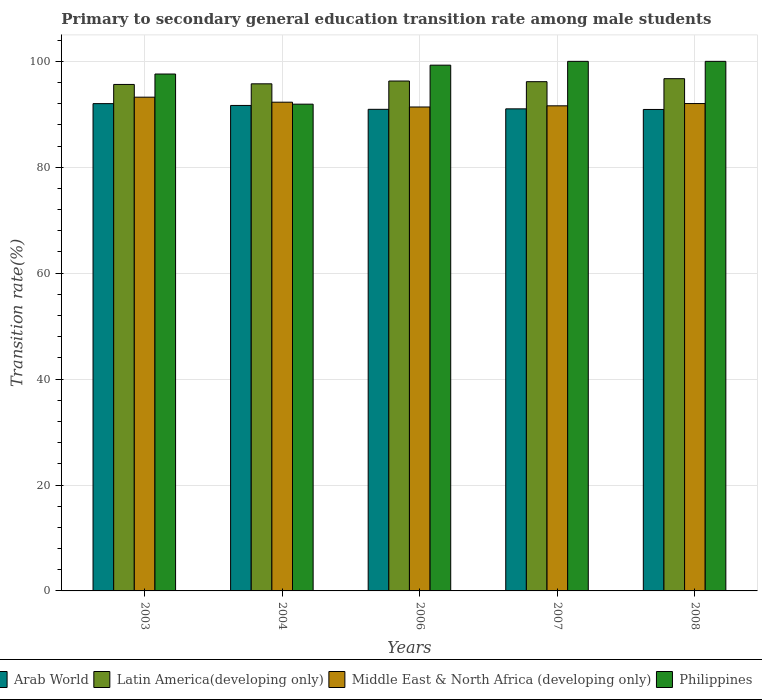Are the number of bars per tick equal to the number of legend labels?
Provide a succinct answer. Yes. Are the number of bars on each tick of the X-axis equal?
Offer a very short reply. Yes. How many bars are there on the 5th tick from the left?
Provide a succinct answer. 4. In how many cases, is the number of bars for a given year not equal to the number of legend labels?
Your answer should be compact. 0. What is the transition rate in Arab World in 2008?
Offer a terse response. 90.92. Across all years, what is the maximum transition rate in Arab World?
Give a very brief answer. 92.02. Across all years, what is the minimum transition rate in Philippines?
Keep it short and to the point. 91.92. In which year was the transition rate in Philippines maximum?
Offer a terse response. 2007. What is the total transition rate in Philippines in the graph?
Give a very brief answer. 488.8. What is the difference between the transition rate in Arab World in 2004 and that in 2006?
Offer a terse response. 0.73. What is the difference between the transition rate in Latin America(developing only) in 2008 and the transition rate in Middle East & North Africa (developing only) in 2006?
Keep it short and to the point. 5.35. What is the average transition rate in Philippines per year?
Offer a terse response. 97.76. In the year 2008, what is the difference between the transition rate in Latin America(developing only) and transition rate in Philippines?
Offer a very short reply. -3.27. In how many years, is the transition rate in Arab World greater than 4 %?
Provide a succinct answer. 5. What is the ratio of the transition rate in Middle East & North Africa (developing only) in 2004 to that in 2007?
Offer a very short reply. 1.01. Is the transition rate in Middle East & North Africa (developing only) in 2006 less than that in 2007?
Provide a short and direct response. Yes. Is the difference between the transition rate in Latin America(developing only) in 2006 and 2007 greater than the difference between the transition rate in Philippines in 2006 and 2007?
Your response must be concise. Yes. What is the difference between the highest and the second highest transition rate in Arab World?
Ensure brevity in your answer.  0.34. What is the difference between the highest and the lowest transition rate in Middle East & North Africa (developing only)?
Give a very brief answer. 1.85. In how many years, is the transition rate in Philippines greater than the average transition rate in Philippines taken over all years?
Give a very brief answer. 3. What does the 3rd bar from the left in 2008 represents?
Offer a very short reply. Middle East & North Africa (developing only). What does the 4th bar from the right in 2007 represents?
Your response must be concise. Arab World. Is it the case that in every year, the sum of the transition rate in Philippines and transition rate in Middle East & North Africa (developing only) is greater than the transition rate in Latin America(developing only)?
Offer a very short reply. Yes. What is the difference between two consecutive major ticks on the Y-axis?
Your response must be concise. 20. Are the values on the major ticks of Y-axis written in scientific E-notation?
Provide a succinct answer. No. Does the graph contain grids?
Provide a succinct answer. Yes. How are the legend labels stacked?
Make the answer very short. Horizontal. What is the title of the graph?
Ensure brevity in your answer.  Primary to secondary general education transition rate among male students. What is the label or title of the X-axis?
Your answer should be compact. Years. What is the label or title of the Y-axis?
Make the answer very short. Transition rate(%). What is the Transition rate(%) in Arab World in 2003?
Ensure brevity in your answer.  92.02. What is the Transition rate(%) of Latin America(developing only) in 2003?
Ensure brevity in your answer.  95.64. What is the Transition rate(%) in Middle East & North Africa (developing only) in 2003?
Make the answer very short. 93.24. What is the Transition rate(%) of Philippines in 2003?
Ensure brevity in your answer.  97.61. What is the Transition rate(%) in Arab World in 2004?
Ensure brevity in your answer.  91.67. What is the Transition rate(%) in Latin America(developing only) in 2004?
Your response must be concise. 95.76. What is the Transition rate(%) in Middle East & North Africa (developing only) in 2004?
Keep it short and to the point. 92.29. What is the Transition rate(%) in Philippines in 2004?
Offer a terse response. 91.92. What is the Transition rate(%) of Arab World in 2006?
Your response must be concise. 90.94. What is the Transition rate(%) of Latin America(developing only) in 2006?
Your response must be concise. 96.29. What is the Transition rate(%) in Middle East & North Africa (developing only) in 2006?
Offer a terse response. 91.38. What is the Transition rate(%) of Philippines in 2006?
Your answer should be compact. 99.28. What is the Transition rate(%) in Arab World in 2007?
Offer a terse response. 91.03. What is the Transition rate(%) of Latin America(developing only) in 2007?
Your answer should be compact. 96.16. What is the Transition rate(%) of Middle East & North Africa (developing only) in 2007?
Make the answer very short. 91.6. What is the Transition rate(%) in Arab World in 2008?
Give a very brief answer. 90.92. What is the Transition rate(%) of Latin America(developing only) in 2008?
Your answer should be compact. 96.73. What is the Transition rate(%) of Middle East & North Africa (developing only) in 2008?
Offer a very short reply. 92.03. Across all years, what is the maximum Transition rate(%) in Arab World?
Your response must be concise. 92.02. Across all years, what is the maximum Transition rate(%) of Latin America(developing only)?
Your response must be concise. 96.73. Across all years, what is the maximum Transition rate(%) of Middle East & North Africa (developing only)?
Ensure brevity in your answer.  93.24. Across all years, what is the minimum Transition rate(%) of Arab World?
Your answer should be very brief. 90.92. Across all years, what is the minimum Transition rate(%) in Latin America(developing only)?
Provide a short and direct response. 95.64. Across all years, what is the minimum Transition rate(%) in Middle East & North Africa (developing only)?
Give a very brief answer. 91.38. Across all years, what is the minimum Transition rate(%) of Philippines?
Make the answer very short. 91.92. What is the total Transition rate(%) of Arab World in the graph?
Offer a very short reply. 456.58. What is the total Transition rate(%) of Latin America(developing only) in the graph?
Your answer should be very brief. 480.57. What is the total Transition rate(%) of Middle East & North Africa (developing only) in the graph?
Give a very brief answer. 460.54. What is the total Transition rate(%) of Philippines in the graph?
Provide a short and direct response. 488.8. What is the difference between the Transition rate(%) in Arab World in 2003 and that in 2004?
Your response must be concise. 0.34. What is the difference between the Transition rate(%) of Latin America(developing only) in 2003 and that in 2004?
Offer a very short reply. -0.12. What is the difference between the Transition rate(%) in Middle East & North Africa (developing only) in 2003 and that in 2004?
Ensure brevity in your answer.  0.95. What is the difference between the Transition rate(%) in Philippines in 2003 and that in 2004?
Offer a very short reply. 5.69. What is the difference between the Transition rate(%) in Arab World in 2003 and that in 2006?
Your answer should be compact. 1.07. What is the difference between the Transition rate(%) in Latin America(developing only) in 2003 and that in 2006?
Your answer should be compact. -0.65. What is the difference between the Transition rate(%) in Middle East & North Africa (developing only) in 2003 and that in 2006?
Your response must be concise. 1.85. What is the difference between the Transition rate(%) in Philippines in 2003 and that in 2006?
Make the answer very short. -1.67. What is the difference between the Transition rate(%) of Arab World in 2003 and that in 2007?
Make the answer very short. 0.99. What is the difference between the Transition rate(%) in Latin America(developing only) in 2003 and that in 2007?
Ensure brevity in your answer.  -0.52. What is the difference between the Transition rate(%) of Middle East & North Africa (developing only) in 2003 and that in 2007?
Keep it short and to the point. 1.63. What is the difference between the Transition rate(%) in Philippines in 2003 and that in 2007?
Your response must be concise. -2.39. What is the difference between the Transition rate(%) in Arab World in 2003 and that in 2008?
Offer a very short reply. 1.1. What is the difference between the Transition rate(%) of Latin America(developing only) in 2003 and that in 2008?
Provide a succinct answer. -1.09. What is the difference between the Transition rate(%) in Middle East & North Africa (developing only) in 2003 and that in 2008?
Provide a succinct answer. 1.2. What is the difference between the Transition rate(%) of Philippines in 2003 and that in 2008?
Provide a short and direct response. -2.39. What is the difference between the Transition rate(%) of Arab World in 2004 and that in 2006?
Offer a very short reply. 0.73. What is the difference between the Transition rate(%) of Latin America(developing only) in 2004 and that in 2006?
Provide a short and direct response. -0.53. What is the difference between the Transition rate(%) in Middle East & North Africa (developing only) in 2004 and that in 2006?
Your answer should be compact. 0.91. What is the difference between the Transition rate(%) in Philippines in 2004 and that in 2006?
Your answer should be compact. -7.37. What is the difference between the Transition rate(%) of Arab World in 2004 and that in 2007?
Your response must be concise. 0.64. What is the difference between the Transition rate(%) in Latin America(developing only) in 2004 and that in 2007?
Your response must be concise. -0.4. What is the difference between the Transition rate(%) of Middle East & North Africa (developing only) in 2004 and that in 2007?
Your answer should be compact. 0.68. What is the difference between the Transition rate(%) of Philippines in 2004 and that in 2007?
Offer a terse response. -8.09. What is the difference between the Transition rate(%) in Arab World in 2004 and that in 2008?
Provide a short and direct response. 0.76. What is the difference between the Transition rate(%) in Latin America(developing only) in 2004 and that in 2008?
Keep it short and to the point. -0.97. What is the difference between the Transition rate(%) in Middle East & North Africa (developing only) in 2004 and that in 2008?
Your answer should be very brief. 0.26. What is the difference between the Transition rate(%) of Philippines in 2004 and that in 2008?
Offer a very short reply. -8.09. What is the difference between the Transition rate(%) in Arab World in 2006 and that in 2007?
Offer a terse response. -0.09. What is the difference between the Transition rate(%) of Latin America(developing only) in 2006 and that in 2007?
Offer a very short reply. 0.13. What is the difference between the Transition rate(%) in Middle East & North Africa (developing only) in 2006 and that in 2007?
Your response must be concise. -0.22. What is the difference between the Transition rate(%) of Philippines in 2006 and that in 2007?
Your answer should be very brief. -0.72. What is the difference between the Transition rate(%) in Arab World in 2006 and that in 2008?
Your answer should be very brief. 0.03. What is the difference between the Transition rate(%) of Latin America(developing only) in 2006 and that in 2008?
Your answer should be very brief. -0.44. What is the difference between the Transition rate(%) of Middle East & North Africa (developing only) in 2006 and that in 2008?
Make the answer very short. -0.65. What is the difference between the Transition rate(%) of Philippines in 2006 and that in 2008?
Keep it short and to the point. -0.72. What is the difference between the Transition rate(%) of Arab World in 2007 and that in 2008?
Make the answer very short. 0.12. What is the difference between the Transition rate(%) in Latin America(developing only) in 2007 and that in 2008?
Give a very brief answer. -0.57. What is the difference between the Transition rate(%) in Middle East & North Africa (developing only) in 2007 and that in 2008?
Your answer should be very brief. -0.43. What is the difference between the Transition rate(%) in Philippines in 2007 and that in 2008?
Offer a terse response. 0. What is the difference between the Transition rate(%) in Arab World in 2003 and the Transition rate(%) in Latin America(developing only) in 2004?
Offer a terse response. -3.74. What is the difference between the Transition rate(%) in Arab World in 2003 and the Transition rate(%) in Middle East & North Africa (developing only) in 2004?
Offer a terse response. -0.27. What is the difference between the Transition rate(%) in Arab World in 2003 and the Transition rate(%) in Philippines in 2004?
Provide a succinct answer. 0.1. What is the difference between the Transition rate(%) of Latin America(developing only) in 2003 and the Transition rate(%) of Middle East & North Africa (developing only) in 2004?
Ensure brevity in your answer.  3.35. What is the difference between the Transition rate(%) of Latin America(developing only) in 2003 and the Transition rate(%) of Philippines in 2004?
Make the answer very short. 3.73. What is the difference between the Transition rate(%) in Middle East & North Africa (developing only) in 2003 and the Transition rate(%) in Philippines in 2004?
Your answer should be very brief. 1.32. What is the difference between the Transition rate(%) of Arab World in 2003 and the Transition rate(%) of Latin America(developing only) in 2006?
Make the answer very short. -4.27. What is the difference between the Transition rate(%) of Arab World in 2003 and the Transition rate(%) of Middle East & North Africa (developing only) in 2006?
Provide a succinct answer. 0.63. What is the difference between the Transition rate(%) of Arab World in 2003 and the Transition rate(%) of Philippines in 2006?
Your answer should be very brief. -7.26. What is the difference between the Transition rate(%) of Latin America(developing only) in 2003 and the Transition rate(%) of Middle East & North Africa (developing only) in 2006?
Ensure brevity in your answer.  4.26. What is the difference between the Transition rate(%) in Latin America(developing only) in 2003 and the Transition rate(%) in Philippines in 2006?
Ensure brevity in your answer.  -3.64. What is the difference between the Transition rate(%) of Middle East & North Africa (developing only) in 2003 and the Transition rate(%) of Philippines in 2006?
Provide a succinct answer. -6.05. What is the difference between the Transition rate(%) in Arab World in 2003 and the Transition rate(%) in Latin America(developing only) in 2007?
Provide a short and direct response. -4.14. What is the difference between the Transition rate(%) in Arab World in 2003 and the Transition rate(%) in Middle East & North Africa (developing only) in 2007?
Offer a very short reply. 0.41. What is the difference between the Transition rate(%) in Arab World in 2003 and the Transition rate(%) in Philippines in 2007?
Your answer should be compact. -7.98. What is the difference between the Transition rate(%) of Latin America(developing only) in 2003 and the Transition rate(%) of Middle East & North Africa (developing only) in 2007?
Provide a succinct answer. 4.04. What is the difference between the Transition rate(%) in Latin America(developing only) in 2003 and the Transition rate(%) in Philippines in 2007?
Offer a terse response. -4.36. What is the difference between the Transition rate(%) in Middle East & North Africa (developing only) in 2003 and the Transition rate(%) in Philippines in 2007?
Keep it short and to the point. -6.76. What is the difference between the Transition rate(%) of Arab World in 2003 and the Transition rate(%) of Latin America(developing only) in 2008?
Keep it short and to the point. -4.71. What is the difference between the Transition rate(%) of Arab World in 2003 and the Transition rate(%) of Middle East & North Africa (developing only) in 2008?
Your answer should be very brief. -0.01. What is the difference between the Transition rate(%) of Arab World in 2003 and the Transition rate(%) of Philippines in 2008?
Your answer should be compact. -7.98. What is the difference between the Transition rate(%) of Latin America(developing only) in 2003 and the Transition rate(%) of Middle East & North Africa (developing only) in 2008?
Ensure brevity in your answer.  3.61. What is the difference between the Transition rate(%) in Latin America(developing only) in 2003 and the Transition rate(%) in Philippines in 2008?
Ensure brevity in your answer.  -4.36. What is the difference between the Transition rate(%) of Middle East & North Africa (developing only) in 2003 and the Transition rate(%) of Philippines in 2008?
Your response must be concise. -6.76. What is the difference between the Transition rate(%) of Arab World in 2004 and the Transition rate(%) of Latin America(developing only) in 2006?
Give a very brief answer. -4.61. What is the difference between the Transition rate(%) in Arab World in 2004 and the Transition rate(%) in Middle East & North Africa (developing only) in 2006?
Provide a succinct answer. 0.29. What is the difference between the Transition rate(%) in Arab World in 2004 and the Transition rate(%) in Philippines in 2006?
Make the answer very short. -7.61. What is the difference between the Transition rate(%) in Latin America(developing only) in 2004 and the Transition rate(%) in Middle East & North Africa (developing only) in 2006?
Keep it short and to the point. 4.37. What is the difference between the Transition rate(%) in Latin America(developing only) in 2004 and the Transition rate(%) in Philippines in 2006?
Make the answer very short. -3.52. What is the difference between the Transition rate(%) in Middle East & North Africa (developing only) in 2004 and the Transition rate(%) in Philippines in 2006?
Give a very brief answer. -6.99. What is the difference between the Transition rate(%) in Arab World in 2004 and the Transition rate(%) in Latin America(developing only) in 2007?
Offer a very short reply. -4.49. What is the difference between the Transition rate(%) of Arab World in 2004 and the Transition rate(%) of Middle East & North Africa (developing only) in 2007?
Offer a terse response. 0.07. What is the difference between the Transition rate(%) in Arab World in 2004 and the Transition rate(%) in Philippines in 2007?
Make the answer very short. -8.33. What is the difference between the Transition rate(%) in Latin America(developing only) in 2004 and the Transition rate(%) in Middle East & North Africa (developing only) in 2007?
Your answer should be compact. 4.15. What is the difference between the Transition rate(%) of Latin America(developing only) in 2004 and the Transition rate(%) of Philippines in 2007?
Ensure brevity in your answer.  -4.24. What is the difference between the Transition rate(%) of Middle East & North Africa (developing only) in 2004 and the Transition rate(%) of Philippines in 2007?
Your response must be concise. -7.71. What is the difference between the Transition rate(%) in Arab World in 2004 and the Transition rate(%) in Latin America(developing only) in 2008?
Provide a succinct answer. -5.05. What is the difference between the Transition rate(%) in Arab World in 2004 and the Transition rate(%) in Middle East & North Africa (developing only) in 2008?
Ensure brevity in your answer.  -0.36. What is the difference between the Transition rate(%) in Arab World in 2004 and the Transition rate(%) in Philippines in 2008?
Give a very brief answer. -8.33. What is the difference between the Transition rate(%) of Latin America(developing only) in 2004 and the Transition rate(%) of Middle East & North Africa (developing only) in 2008?
Offer a very short reply. 3.73. What is the difference between the Transition rate(%) of Latin America(developing only) in 2004 and the Transition rate(%) of Philippines in 2008?
Ensure brevity in your answer.  -4.24. What is the difference between the Transition rate(%) in Middle East & North Africa (developing only) in 2004 and the Transition rate(%) in Philippines in 2008?
Offer a terse response. -7.71. What is the difference between the Transition rate(%) of Arab World in 2006 and the Transition rate(%) of Latin America(developing only) in 2007?
Give a very brief answer. -5.22. What is the difference between the Transition rate(%) of Arab World in 2006 and the Transition rate(%) of Middle East & North Africa (developing only) in 2007?
Offer a very short reply. -0.66. What is the difference between the Transition rate(%) of Arab World in 2006 and the Transition rate(%) of Philippines in 2007?
Make the answer very short. -9.06. What is the difference between the Transition rate(%) of Latin America(developing only) in 2006 and the Transition rate(%) of Middle East & North Africa (developing only) in 2007?
Ensure brevity in your answer.  4.68. What is the difference between the Transition rate(%) of Latin America(developing only) in 2006 and the Transition rate(%) of Philippines in 2007?
Your answer should be compact. -3.71. What is the difference between the Transition rate(%) in Middle East & North Africa (developing only) in 2006 and the Transition rate(%) in Philippines in 2007?
Your answer should be compact. -8.62. What is the difference between the Transition rate(%) of Arab World in 2006 and the Transition rate(%) of Latin America(developing only) in 2008?
Give a very brief answer. -5.79. What is the difference between the Transition rate(%) of Arab World in 2006 and the Transition rate(%) of Middle East & North Africa (developing only) in 2008?
Your response must be concise. -1.09. What is the difference between the Transition rate(%) of Arab World in 2006 and the Transition rate(%) of Philippines in 2008?
Give a very brief answer. -9.06. What is the difference between the Transition rate(%) in Latin America(developing only) in 2006 and the Transition rate(%) in Middle East & North Africa (developing only) in 2008?
Your answer should be compact. 4.25. What is the difference between the Transition rate(%) in Latin America(developing only) in 2006 and the Transition rate(%) in Philippines in 2008?
Provide a succinct answer. -3.71. What is the difference between the Transition rate(%) of Middle East & North Africa (developing only) in 2006 and the Transition rate(%) of Philippines in 2008?
Your answer should be very brief. -8.62. What is the difference between the Transition rate(%) of Arab World in 2007 and the Transition rate(%) of Latin America(developing only) in 2008?
Make the answer very short. -5.7. What is the difference between the Transition rate(%) in Arab World in 2007 and the Transition rate(%) in Middle East & North Africa (developing only) in 2008?
Ensure brevity in your answer.  -1. What is the difference between the Transition rate(%) in Arab World in 2007 and the Transition rate(%) in Philippines in 2008?
Offer a very short reply. -8.97. What is the difference between the Transition rate(%) in Latin America(developing only) in 2007 and the Transition rate(%) in Middle East & North Africa (developing only) in 2008?
Provide a short and direct response. 4.13. What is the difference between the Transition rate(%) of Latin America(developing only) in 2007 and the Transition rate(%) of Philippines in 2008?
Your answer should be very brief. -3.84. What is the difference between the Transition rate(%) of Middle East & North Africa (developing only) in 2007 and the Transition rate(%) of Philippines in 2008?
Provide a succinct answer. -8.4. What is the average Transition rate(%) in Arab World per year?
Offer a very short reply. 91.32. What is the average Transition rate(%) in Latin America(developing only) per year?
Your answer should be very brief. 96.11. What is the average Transition rate(%) in Middle East & North Africa (developing only) per year?
Provide a short and direct response. 92.11. What is the average Transition rate(%) in Philippines per year?
Provide a short and direct response. 97.76. In the year 2003, what is the difference between the Transition rate(%) of Arab World and Transition rate(%) of Latin America(developing only)?
Offer a terse response. -3.62. In the year 2003, what is the difference between the Transition rate(%) of Arab World and Transition rate(%) of Middle East & North Africa (developing only)?
Offer a very short reply. -1.22. In the year 2003, what is the difference between the Transition rate(%) of Arab World and Transition rate(%) of Philippines?
Keep it short and to the point. -5.59. In the year 2003, what is the difference between the Transition rate(%) of Latin America(developing only) and Transition rate(%) of Middle East & North Africa (developing only)?
Your answer should be very brief. 2.41. In the year 2003, what is the difference between the Transition rate(%) of Latin America(developing only) and Transition rate(%) of Philippines?
Offer a very short reply. -1.97. In the year 2003, what is the difference between the Transition rate(%) in Middle East & North Africa (developing only) and Transition rate(%) in Philippines?
Your answer should be compact. -4.37. In the year 2004, what is the difference between the Transition rate(%) in Arab World and Transition rate(%) in Latin America(developing only)?
Offer a terse response. -4.08. In the year 2004, what is the difference between the Transition rate(%) in Arab World and Transition rate(%) in Middle East & North Africa (developing only)?
Keep it short and to the point. -0.61. In the year 2004, what is the difference between the Transition rate(%) in Arab World and Transition rate(%) in Philippines?
Keep it short and to the point. -0.24. In the year 2004, what is the difference between the Transition rate(%) of Latin America(developing only) and Transition rate(%) of Middle East & North Africa (developing only)?
Your answer should be compact. 3.47. In the year 2004, what is the difference between the Transition rate(%) in Latin America(developing only) and Transition rate(%) in Philippines?
Make the answer very short. 3.84. In the year 2004, what is the difference between the Transition rate(%) of Middle East & North Africa (developing only) and Transition rate(%) of Philippines?
Ensure brevity in your answer.  0.37. In the year 2006, what is the difference between the Transition rate(%) of Arab World and Transition rate(%) of Latin America(developing only)?
Make the answer very short. -5.34. In the year 2006, what is the difference between the Transition rate(%) in Arab World and Transition rate(%) in Middle East & North Africa (developing only)?
Provide a succinct answer. -0.44. In the year 2006, what is the difference between the Transition rate(%) of Arab World and Transition rate(%) of Philippines?
Provide a short and direct response. -8.34. In the year 2006, what is the difference between the Transition rate(%) in Latin America(developing only) and Transition rate(%) in Middle East & North Africa (developing only)?
Provide a succinct answer. 4.9. In the year 2006, what is the difference between the Transition rate(%) in Latin America(developing only) and Transition rate(%) in Philippines?
Your answer should be very brief. -2.99. In the year 2006, what is the difference between the Transition rate(%) in Middle East & North Africa (developing only) and Transition rate(%) in Philippines?
Provide a succinct answer. -7.9. In the year 2007, what is the difference between the Transition rate(%) in Arab World and Transition rate(%) in Latin America(developing only)?
Your answer should be very brief. -5.13. In the year 2007, what is the difference between the Transition rate(%) of Arab World and Transition rate(%) of Middle East & North Africa (developing only)?
Provide a short and direct response. -0.57. In the year 2007, what is the difference between the Transition rate(%) of Arab World and Transition rate(%) of Philippines?
Offer a terse response. -8.97. In the year 2007, what is the difference between the Transition rate(%) in Latin America(developing only) and Transition rate(%) in Middle East & North Africa (developing only)?
Provide a succinct answer. 4.56. In the year 2007, what is the difference between the Transition rate(%) in Latin America(developing only) and Transition rate(%) in Philippines?
Your answer should be compact. -3.84. In the year 2007, what is the difference between the Transition rate(%) of Middle East & North Africa (developing only) and Transition rate(%) of Philippines?
Keep it short and to the point. -8.4. In the year 2008, what is the difference between the Transition rate(%) of Arab World and Transition rate(%) of Latin America(developing only)?
Your answer should be very brief. -5.81. In the year 2008, what is the difference between the Transition rate(%) in Arab World and Transition rate(%) in Middle East & North Africa (developing only)?
Offer a very short reply. -1.12. In the year 2008, what is the difference between the Transition rate(%) of Arab World and Transition rate(%) of Philippines?
Ensure brevity in your answer.  -9.08. In the year 2008, what is the difference between the Transition rate(%) of Latin America(developing only) and Transition rate(%) of Middle East & North Africa (developing only)?
Provide a short and direct response. 4.7. In the year 2008, what is the difference between the Transition rate(%) in Latin America(developing only) and Transition rate(%) in Philippines?
Ensure brevity in your answer.  -3.27. In the year 2008, what is the difference between the Transition rate(%) in Middle East & North Africa (developing only) and Transition rate(%) in Philippines?
Offer a very short reply. -7.97. What is the ratio of the Transition rate(%) in Latin America(developing only) in 2003 to that in 2004?
Provide a short and direct response. 1. What is the ratio of the Transition rate(%) of Middle East & North Africa (developing only) in 2003 to that in 2004?
Keep it short and to the point. 1.01. What is the ratio of the Transition rate(%) in Philippines in 2003 to that in 2004?
Ensure brevity in your answer.  1.06. What is the ratio of the Transition rate(%) of Arab World in 2003 to that in 2006?
Your answer should be very brief. 1.01. What is the ratio of the Transition rate(%) in Latin America(developing only) in 2003 to that in 2006?
Offer a very short reply. 0.99. What is the ratio of the Transition rate(%) of Middle East & North Africa (developing only) in 2003 to that in 2006?
Your response must be concise. 1.02. What is the ratio of the Transition rate(%) in Philippines in 2003 to that in 2006?
Provide a succinct answer. 0.98. What is the ratio of the Transition rate(%) in Arab World in 2003 to that in 2007?
Offer a terse response. 1.01. What is the ratio of the Transition rate(%) in Middle East & North Africa (developing only) in 2003 to that in 2007?
Your answer should be very brief. 1.02. What is the ratio of the Transition rate(%) in Philippines in 2003 to that in 2007?
Offer a terse response. 0.98. What is the ratio of the Transition rate(%) in Arab World in 2003 to that in 2008?
Give a very brief answer. 1.01. What is the ratio of the Transition rate(%) in Middle East & North Africa (developing only) in 2003 to that in 2008?
Offer a terse response. 1.01. What is the ratio of the Transition rate(%) in Philippines in 2003 to that in 2008?
Make the answer very short. 0.98. What is the ratio of the Transition rate(%) of Arab World in 2004 to that in 2006?
Your answer should be compact. 1.01. What is the ratio of the Transition rate(%) in Latin America(developing only) in 2004 to that in 2006?
Offer a terse response. 0.99. What is the ratio of the Transition rate(%) in Middle East & North Africa (developing only) in 2004 to that in 2006?
Ensure brevity in your answer.  1.01. What is the ratio of the Transition rate(%) in Philippines in 2004 to that in 2006?
Offer a terse response. 0.93. What is the ratio of the Transition rate(%) in Arab World in 2004 to that in 2007?
Your answer should be compact. 1.01. What is the ratio of the Transition rate(%) of Middle East & North Africa (developing only) in 2004 to that in 2007?
Give a very brief answer. 1.01. What is the ratio of the Transition rate(%) of Philippines in 2004 to that in 2007?
Your answer should be compact. 0.92. What is the ratio of the Transition rate(%) of Arab World in 2004 to that in 2008?
Give a very brief answer. 1.01. What is the ratio of the Transition rate(%) in Latin America(developing only) in 2004 to that in 2008?
Give a very brief answer. 0.99. What is the ratio of the Transition rate(%) in Middle East & North Africa (developing only) in 2004 to that in 2008?
Ensure brevity in your answer.  1. What is the ratio of the Transition rate(%) of Philippines in 2004 to that in 2008?
Provide a succinct answer. 0.92. What is the ratio of the Transition rate(%) of Latin America(developing only) in 2006 to that in 2007?
Make the answer very short. 1. What is the ratio of the Transition rate(%) of Middle East & North Africa (developing only) in 2006 to that in 2007?
Offer a terse response. 1. What is the ratio of the Transition rate(%) of Arab World in 2006 to that in 2008?
Ensure brevity in your answer.  1. What is the ratio of the Transition rate(%) in Philippines in 2006 to that in 2008?
Your answer should be very brief. 0.99. What is the ratio of the Transition rate(%) of Latin America(developing only) in 2007 to that in 2008?
Make the answer very short. 0.99. What is the ratio of the Transition rate(%) of Middle East & North Africa (developing only) in 2007 to that in 2008?
Give a very brief answer. 1. What is the difference between the highest and the second highest Transition rate(%) of Arab World?
Make the answer very short. 0.34. What is the difference between the highest and the second highest Transition rate(%) of Latin America(developing only)?
Give a very brief answer. 0.44. What is the difference between the highest and the second highest Transition rate(%) in Middle East & North Africa (developing only)?
Give a very brief answer. 0.95. What is the difference between the highest and the second highest Transition rate(%) in Philippines?
Offer a terse response. 0. What is the difference between the highest and the lowest Transition rate(%) in Arab World?
Your response must be concise. 1.1. What is the difference between the highest and the lowest Transition rate(%) of Latin America(developing only)?
Provide a succinct answer. 1.09. What is the difference between the highest and the lowest Transition rate(%) of Middle East & North Africa (developing only)?
Offer a terse response. 1.85. What is the difference between the highest and the lowest Transition rate(%) in Philippines?
Your response must be concise. 8.09. 